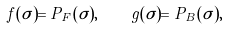Convert formula to latex. <formula><loc_0><loc_0><loc_500><loc_500>f ( \sigma ) = P _ { F } ( \sigma ) , \quad g ( \sigma ) = P _ { B } ( \sigma ) ,</formula> 